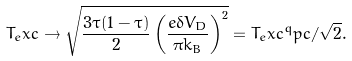Convert formula to latex. <formula><loc_0><loc_0><loc_500><loc_500>T _ { e } x c \rightarrow \sqrt { \frac { 3 \tau ( 1 - \tau ) } { 2 } \left ( \frac { e \delta V _ { D } } { \pi k _ { B } } \right ) ^ { 2 } } = T _ { e } x c ^ { q } p c / \sqrt { 2 } .</formula> 